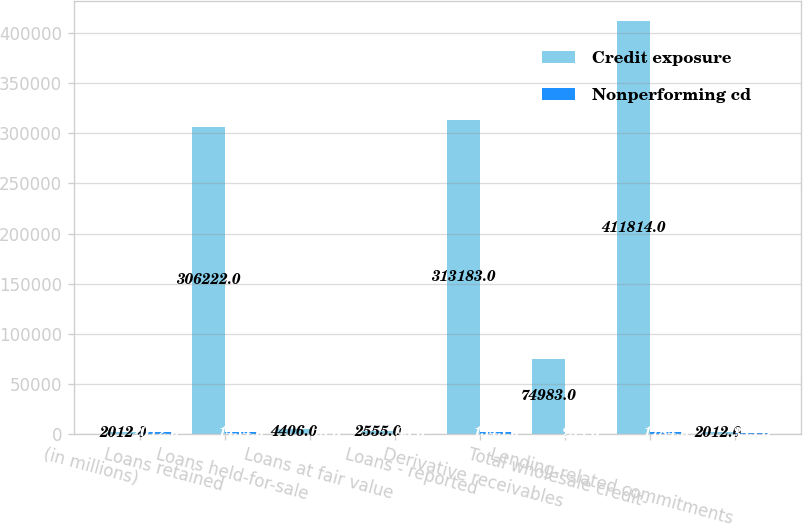<chart> <loc_0><loc_0><loc_500><loc_500><stacked_bar_chart><ecel><fcel>(in millions)<fcel>Loans retained<fcel>Loans held-for-sale<fcel>Loans at fair value<fcel>Loans - reported<fcel>Derivative receivables<fcel>Total wholesale credit-<fcel>Lending-related commitments<nl><fcel>Credit exposure<fcel>2012<fcel>306222<fcel>4406<fcel>2555<fcel>313183<fcel>74983<fcel>411814<fcel>2012<nl><fcel>Nonperforming cd<fcel>2012<fcel>1434<fcel>18<fcel>93<fcel>1545<fcel>239<fcel>1784<fcel>355<nl></chart> 